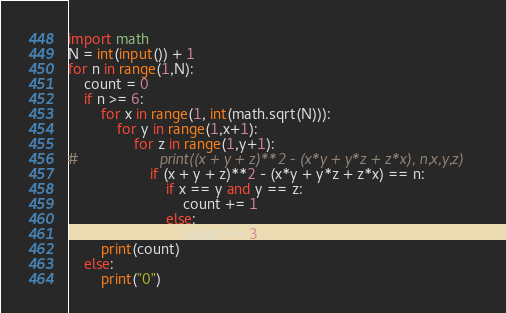<code> <loc_0><loc_0><loc_500><loc_500><_Python_>import math
N = int(input()) + 1
for n in range(1,N):
    count = 0
    if n >= 6:
        for x in range(1, int(math.sqrt(N))):
            for y in range(1,x+1):
                for z in range(1,y+1):
#                    print((x + y + z)**2 - (x*y + y*z + z*x), n,x,y,z)
                    if (x + y + z)**2 - (x*y + y*z + z*x) == n:
                        if x == y and y == z:
                            count += 1
                        else:
                            count += 3
        print(count)            
    else:
        print("0")</code> 